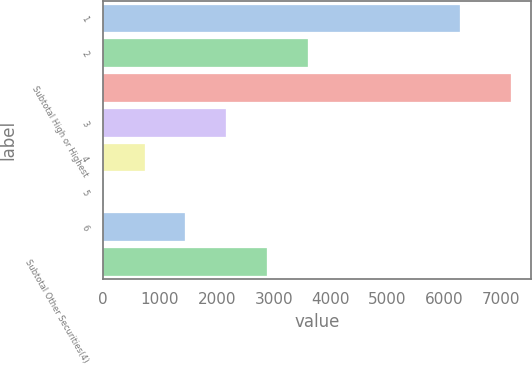Convert chart to OTSL. <chart><loc_0><loc_0><loc_500><loc_500><bar_chart><fcel>1<fcel>2<fcel>Subtotal High or Highest<fcel>3<fcel>4<fcel>5<fcel>6<fcel>Subtotal Other Securities(4)<nl><fcel>6278<fcel>3595.5<fcel>7170<fcel>2165.7<fcel>735.9<fcel>21<fcel>1450.8<fcel>2880.6<nl></chart> 